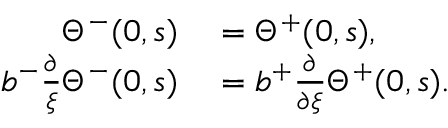<formula> <loc_0><loc_0><loc_500><loc_500>\begin{array} { r l } { \Theta ^ { - } ( 0 , s ) } & = \Theta ^ { + } ( 0 , s ) , } \\ { b ^ { - } \frac { \partial } { \xi } \Theta ^ { - } ( 0 , s ) } & = b ^ { + } \frac { \partial } { \partial \xi } \Theta ^ { + } ( 0 , s ) . } \end{array}</formula> 